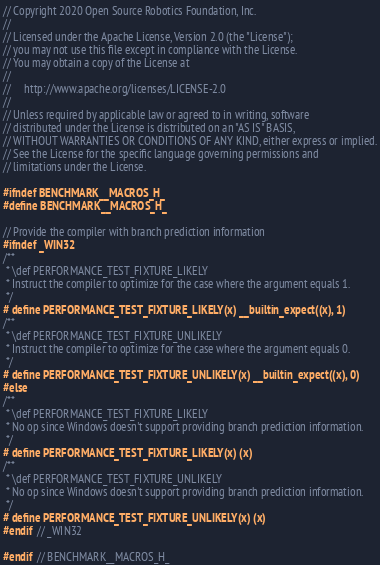<code> <loc_0><loc_0><loc_500><loc_500><_C_>// Copyright 2020 Open Source Robotics Foundation, Inc.
//
// Licensed under the Apache License, Version 2.0 (the "License");
// you may not use this file except in compliance with the License.
// You may obtain a copy of the License at
//
//     http://www.apache.org/licenses/LICENSE-2.0
//
// Unless required by applicable law or agreed to in writing, software
// distributed under the License is distributed on an "AS IS" BASIS,
// WITHOUT WARRANTIES OR CONDITIONS OF ANY KIND, either express or implied.
// See the License for the specific language governing permissions and
// limitations under the License.

#ifndef BENCHMARK__MACROS_H_
#define BENCHMARK__MACROS_H_

// Provide the compiler with branch prediction information
#ifndef _WIN32
/**
 * \def PERFORMANCE_TEST_FIXTURE_LIKELY
 * Instruct the compiler to optimize for the case where the argument equals 1.
 */
# define PERFORMANCE_TEST_FIXTURE_LIKELY(x) __builtin_expect((x), 1)
/**
 * \def PERFORMANCE_TEST_FIXTURE_UNLIKELY
 * Instruct the compiler to optimize for the case where the argument equals 0.
 */
# define PERFORMANCE_TEST_FIXTURE_UNLIKELY(x) __builtin_expect((x), 0)
#else
/**
 * \def PERFORMANCE_TEST_FIXTURE_LIKELY
 * No op since Windows doesn't support providing branch prediction information.
 */
# define PERFORMANCE_TEST_FIXTURE_LIKELY(x) (x)
/**
 * \def PERFORMANCE_TEST_FIXTURE_UNLIKELY
 * No op since Windows doesn't support providing branch prediction information.
 */
# define PERFORMANCE_TEST_FIXTURE_UNLIKELY(x) (x)
#endif  // _WIN32

#endif  // BENCHMARK__MACROS_H_
</code> 